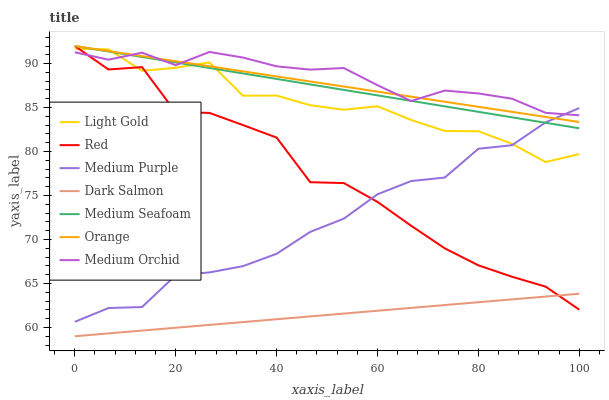Does Dark Salmon have the minimum area under the curve?
Answer yes or no. Yes. Does Medium Orchid have the maximum area under the curve?
Answer yes or no. Yes. Does Medium Purple have the minimum area under the curve?
Answer yes or no. No. Does Medium Purple have the maximum area under the curve?
Answer yes or no. No. Is Medium Seafoam the smoothest?
Answer yes or no. Yes. Is Red the roughest?
Answer yes or no. Yes. Is Dark Salmon the smoothest?
Answer yes or no. No. Is Dark Salmon the roughest?
Answer yes or no. No. Does Dark Salmon have the lowest value?
Answer yes or no. Yes. Does Medium Purple have the lowest value?
Answer yes or no. No. Does Red have the highest value?
Answer yes or no. Yes. Does Medium Purple have the highest value?
Answer yes or no. No. Is Dark Salmon less than Medium Purple?
Answer yes or no. Yes. Is Medium Seafoam greater than Dark Salmon?
Answer yes or no. Yes. Does Light Gold intersect Medium Purple?
Answer yes or no. Yes. Is Light Gold less than Medium Purple?
Answer yes or no. No. Is Light Gold greater than Medium Purple?
Answer yes or no. No. Does Dark Salmon intersect Medium Purple?
Answer yes or no. No. 